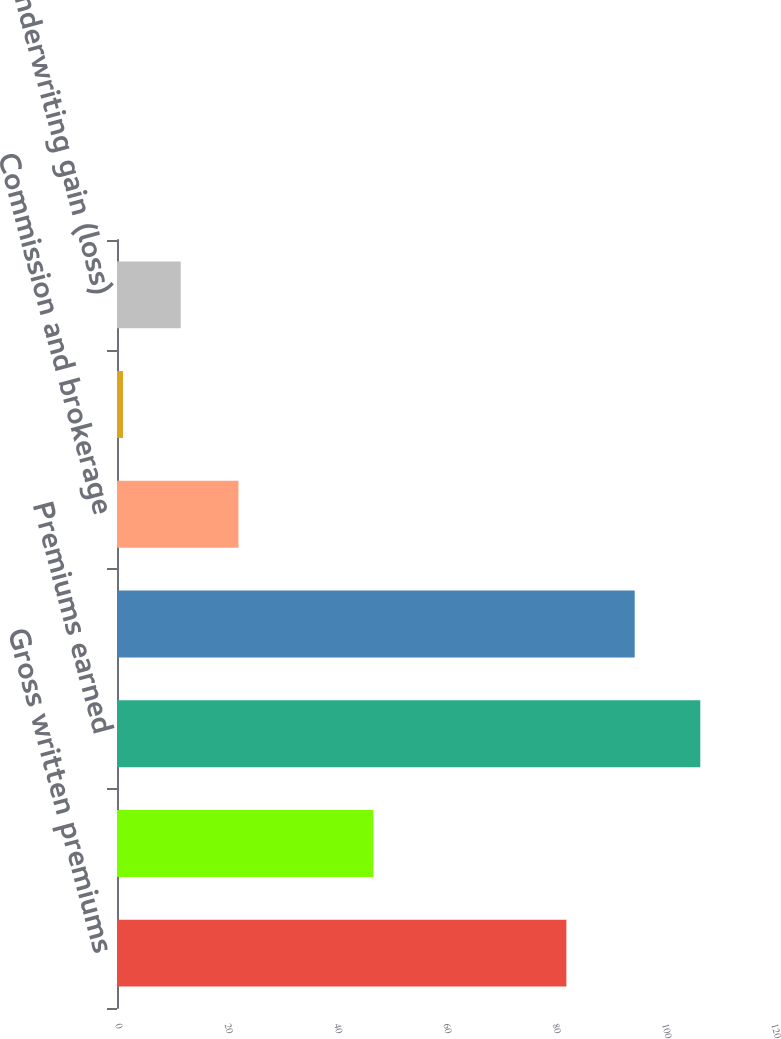<chart> <loc_0><loc_0><loc_500><loc_500><bar_chart><fcel>Gross written premiums<fcel>Net written premiums<fcel>Premiums earned<fcel>Incurred losses and LAE<fcel>Commission and brokerage<fcel>Other underwriting expenses<fcel>Underwriting gain (loss)<nl><fcel>82.2<fcel>46.9<fcel>106.7<fcel>94.7<fcel>22.22<fcel>1.1<fcel>11.66<nl></chart> 